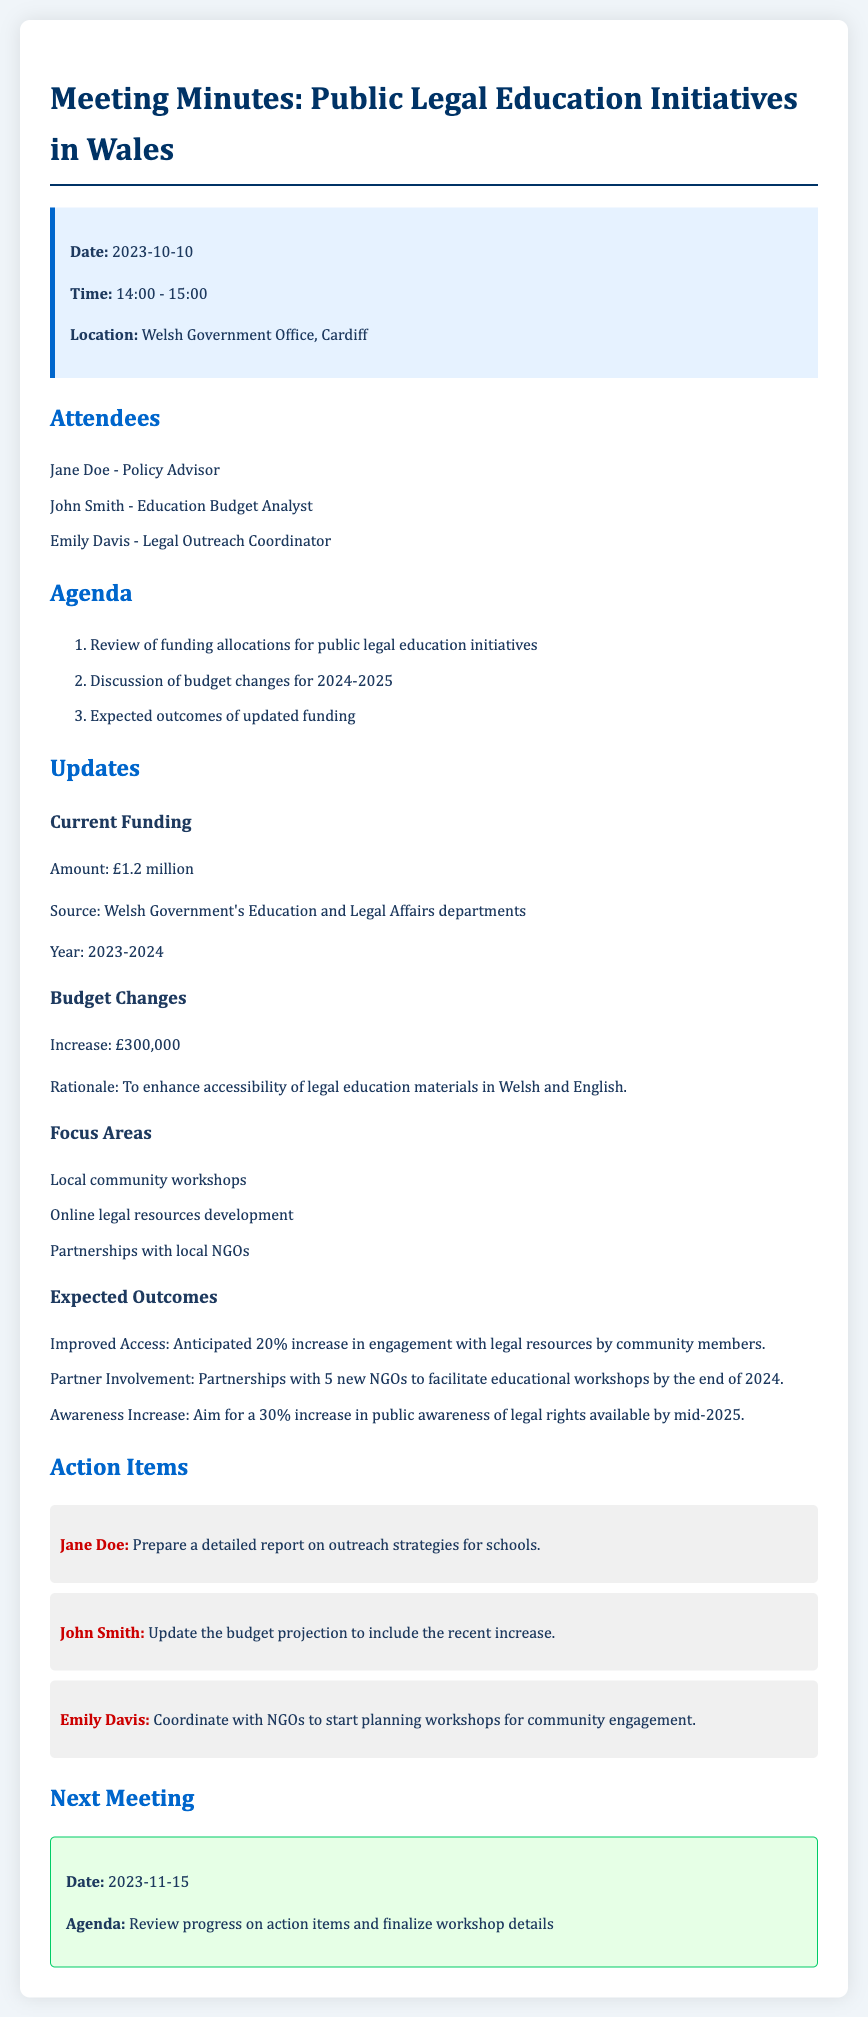what is the current funding amount? The current funding amount is stated in the document as £1.2 million.
Answer: £1.2 million what is the date of the next meeting? The next meeting date is mentioned in the document under 'Next Meeting'.
Answer: 2023-11-15 who is responsible for preparing a report on outreach strategies? The action item outlines that Jane Doe is tasked with preparing a report.
Answer: Jane Doe what is the increase in funding for 2024-2025? The document specifies the funding increase as £300,000.
Answer: £300,000 what percentage increase in engagement with legal resources is anticipated? The expected outcome details a 20% increase in engagement with legal resources.
Answer: 20% what are the focus areas for funding allocation? The document lists several focus areas, including local community workshops and online resources development.
Answer: Local community workshops, online legal resources development, partnerships with local NGOs how many new NGOs are expected to be partnered with? The expected outcome mentions forming partnerships with 5 new NGOs.
Answer: 5 what is the main rationale for the budget increase? The justification for the budget increase is to enhance accessibility of legal education materials.
Answer: Enhance accessibility of legal education materials what is the aim for increasing public awareness of legal rights? The expected outcome states the aim is a 30% increase in public awareness.
Answer: 30% 